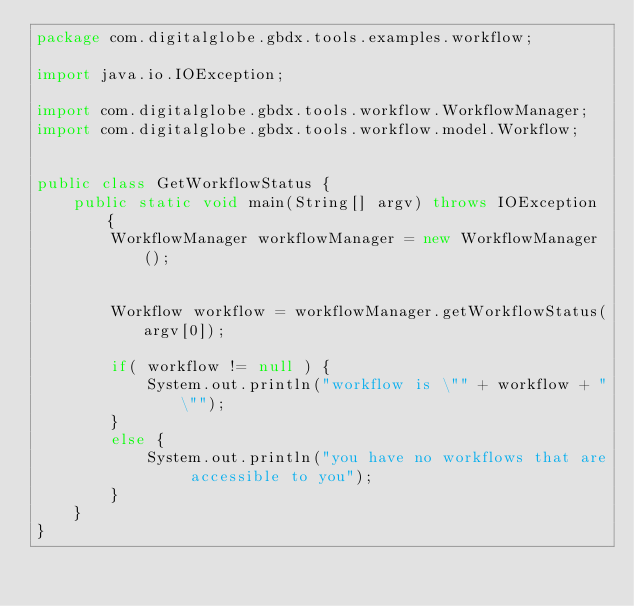Convert code to text. <code><loc_0><loc_0><loc_500><loc_500><_Java_>package com.digitalglobe.gbdx.tools.examples.workflow;

import java.io.IOException;

import com.digitalglobe.gbdx.tools.workflow.WorkflowManager;
import com.digitalglobe.gbdx.tools.workflow.model.Workflow;


public class GetWorkflowStatus {
    public static void main(String[] argv) throws IOException {
        WorkflowManager workflowManager = new WorkflowManager();


        Workflow workflow = workflowManager.getWorkflowStatus(argv[0]);

        if( workflow != null ) {
            System.out.println("workflow is \"" + workflow + "\"");
        }
        else {
            System.out.println("you have no workflows that are accessible to you");
        }
    }
}
</code> 